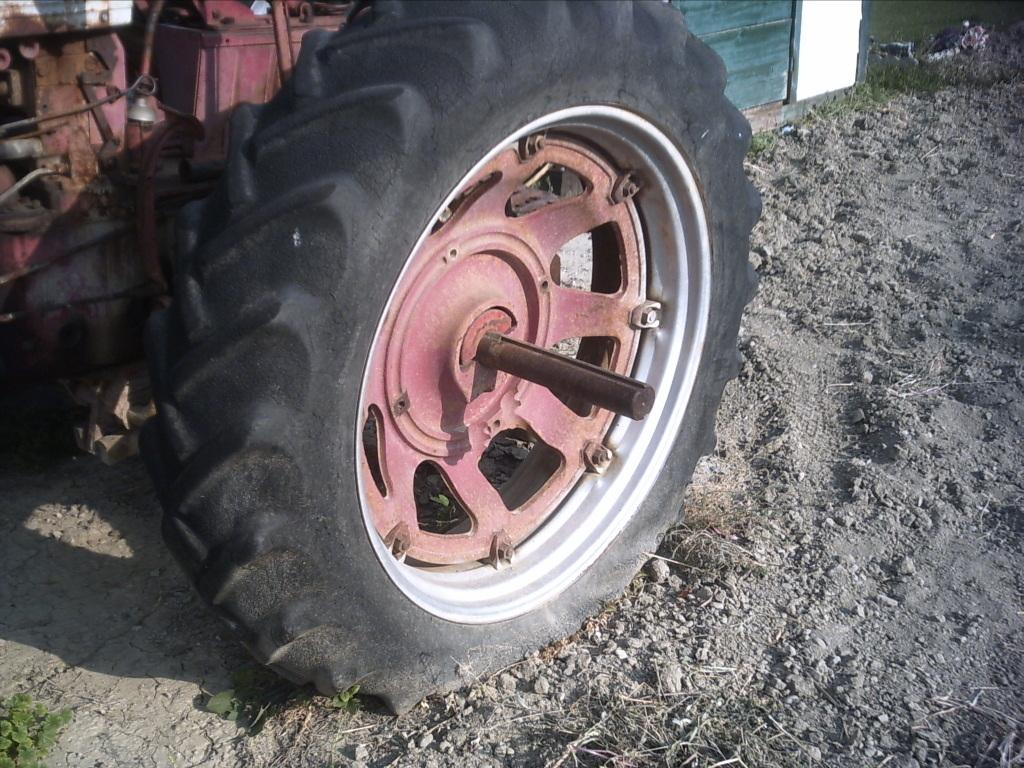What is the main subject of the picture? The main subject of the picture is a tractor. Can you describe any other elements in the background of the picture? There appears to be a door in the background of the picture. What type of hammer is being used to pick berries in the image? There is no hammer or berries present in the image; it features a tractor and a door in the background. 